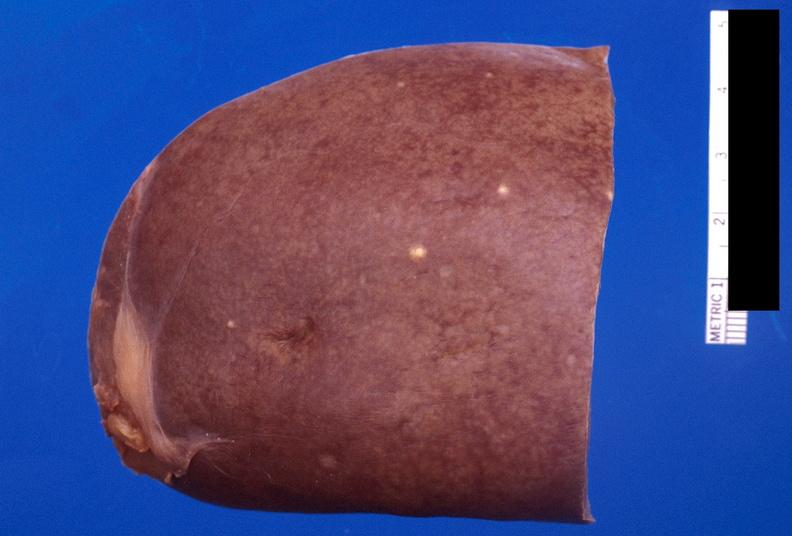does this great toe show spleen, fungal abscesses, candida?
Answer the question using a single word or phrase. No 